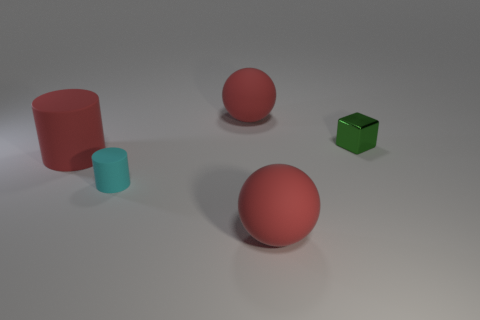Add 3 small rubber objects. How many objects exist? 8 Subtract all balls. How many objects are left? 3 Subtract 0 green cylinders. How many objects are left? 5 Subtract all small shiny things. Subtract all small metallic objects. How many objects are left? 3 Add 4 cyan matte objects. How many cyan matte objects are left? 5 Add 1 cyan rubber things. How many cyan rubber things exist? 2 